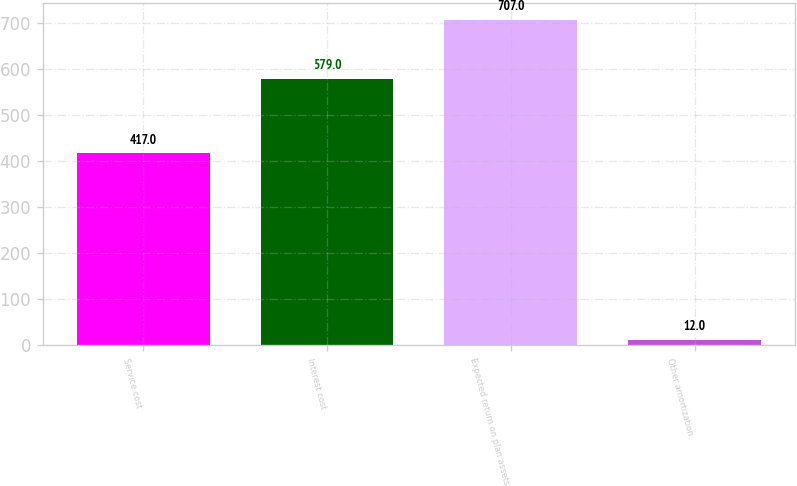Convert chart. <chart><loc_0><loc_0><loc_500><loc_500><bar_chart><fcel>Service cost<fcel>Interest cost<fcel>Expected return on plan assets<fcel>Other amortization<nl><fcel>417<fcel>579<fcel>707<fcel>12<nl></chart> 